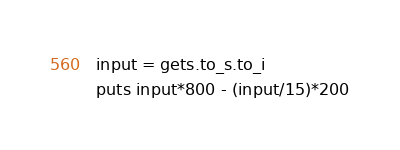<code> <loc_0><loc_0><loc_500><loc_500><_Crystal_>input = gets.to_s.to_i
puts input*800 - (input/15)*200</code> 